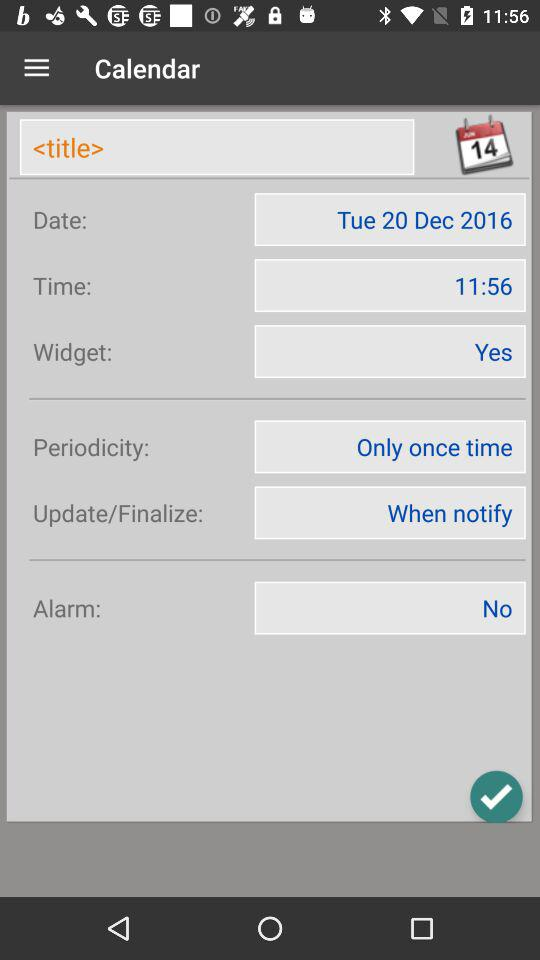What's the date in the calendar? The date is Tuesday, December 20, 2016. 